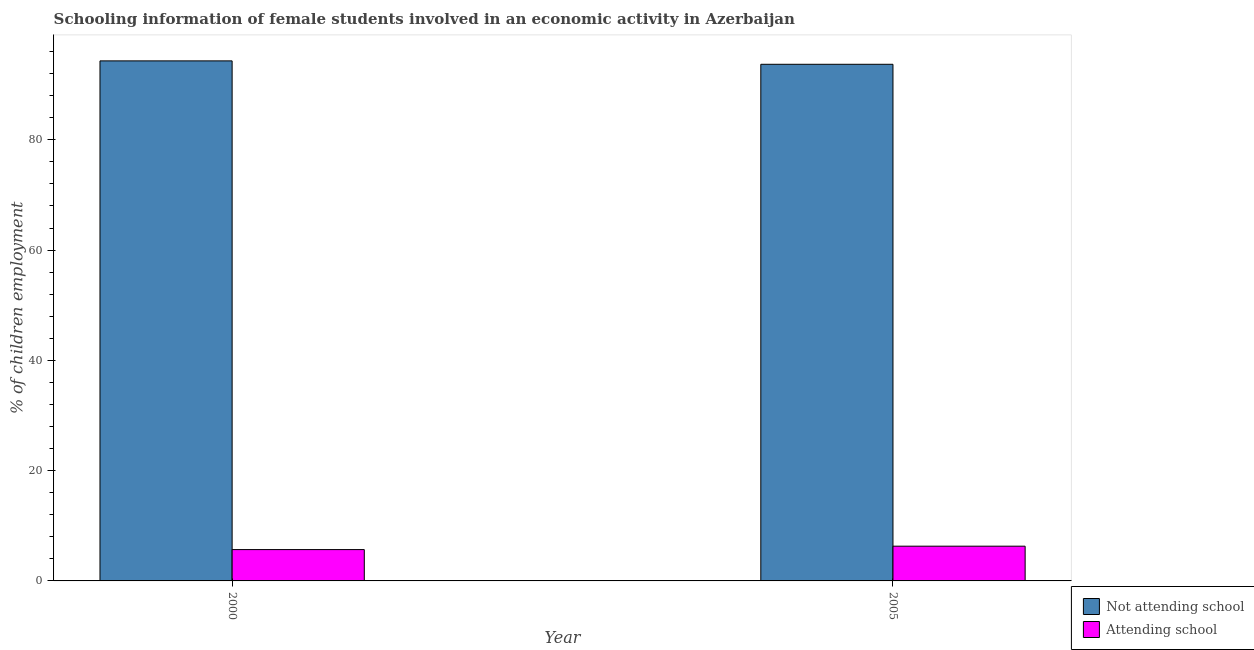What is the label of the 2nd group of bars from the left?
Keep it short and to the point. 2005. In how many cases, is the number of bars for a given year not equal to the number of legend labels?
Offer a very short reply. 0. What is the percentage of employed females who are not attending school in 2000?
Ensure brevity in your answer.  94.32. Across all years, what is the maximum percentage of employed females who are attending school?
Provide a succinct answer. 6.3. Across all years, what is the minimum percentage of employed females who are not attending school?
Offer a terse response. 93.7. In which year was the percentage of employed females who are attending school maximum?
Ensure brevity in your answer.  2005. What is the total percentage of employed females who are not attending school in the graph?
Your response must be concise. 188.02. What is the difference between the percentage of employed females who are not attending school in 2000 and that in 2005?
Provide a succinct answer. 0.62. What is the difference between the percentage of employed females who are attending school in 2005 and the percentage of employed females who are not attending school in 2000?
Offer a terse response. 0.62. What is the average percentage of employed females who are attending school per year?
Provide a short and direct response. 5.99. In the year 2005, what is the difference between the percentage of employed females who are not attending school and percentage of employed females who are attending school?
Keep it short and to the point. 0. In how many years, is the percentage of employed females who are not attending school greater than 28 %?
Make the answer very short. 2. What is the ratio of the percentage of employed females who are not attending school in 2000 to that in 2005?
Make the answer very short. 1.01. Is the percentage of employed females who are not attending school in 2000 less than that in 2005?
Your answer should be compact. No. What does the 1st bar from the left in 2000 represents?
Provide a succinct answer. Not attending school. What does the 2nd bar from the right in 2005 represents?
Make the answer very short. Not attending school. Are all the bars in the graph horizontal?
Offer a terse response. No. What is the difference between two consecutive major ticks on the Y-axis?
Ensure brevity in your answer.  20. Are the values on the major ticks of Y-axis written in scientific E-notation?
Ensure brevity in your answer.  No. Does the graph contain any zero values?
Make the answer very short. No. Does the graph contain grids?
Ensure brevity in your answer.  No. Where does the legend appear in the graph?
Give a very brief answer. Bottom right. How are the legend labels stacked?
Provide a succinct answer. Vertical. What is the title of the graph?
Make the answer very short. Schooling information of female students involved in an economic activity in Azerbaijan. What is the label or title of the X-axis?
Provide a succinct answer. Year. What is the label or title of the Y-axis?
Your answer should be compact. % of children employment. What is the % of children employment of Not attending school in 2000?
Your answer should be compact. 94.32. What is the % of children employment in Attending school in 2000?
Provide a short and direct response. 5.68. What is the % of children employment in Not attending school in 2005?
Offer a terse response. 93.7. Across all years, what is the maximum % of children employment of Not attending school?
Provide a succinct answer. 94.32. Across all years, what is the minimum % of children employment in Not attending school?
Give a very brief answer. 93.7. Across all years, what is the minimum % of children employment in Attending school?
Your response must be concise. 5.68. What is the total % of children employment of Not attending school in the graph?
Offer a terse response. 188.02. What is the total % of children employment of Attending school in the graph?
Make the answer very short. 11.98. What is the difference between the % of children employment in Not attending school in 2000 and that in 2005?
Your answer should be compact. 0.62. What is the difference between the % of children employment in Attending school in 2000 and that in 2005?
Keep it short and to the point. -0.62. What is the difference between the % of children employment of Not attending school in 2000 and the % of children employment of Attending school in 2005?
Your response must be concise. 88.02. What is the average % of children employment in Not attending school per year?
Your answer should be very brief. 94.01. What is the average % of children employment in Attending school per year?
Keep it short and to the point. 5.99. In the year 2000, what is the difference between the % of children employment in Not attending school and % of children employment in Attending school?
Make the answer very short. 88.64. In the year 2005, what is the difference between the % of children employment in Not attending school and % of children employment in Attending school?
Ensure brevity in your answer.  87.4. What is the ratio of the % of children employment in Not attending school in 2000 to that in 2005?
Your response must be concise. 1.01. What is the ratio of the % of children employment of Attending school in 2000 to that in 2005?
Your answer should be compact. 0.9. What is the difference between the highest and the second highest % of children employment of Not attending school?
Provide a short and direct response. 0.62. What is the difference between the highest and the second highest % of children employment in Attending school?
Your answer should be very brief. 0.62. What is the difference between the highest and the lowest % of children employment of Not attending school?
Offer a terse response. 0.62. What is the difference between the highest and the lowest % of children employment in Attending school?
Your response must be concise. 0.62. 